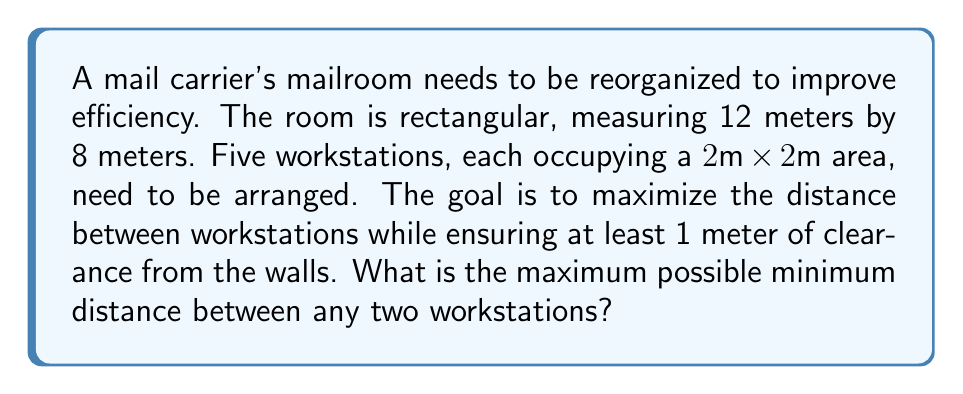Teach me how to tackle this problem. To solve this optimization problem, we'll follow these steps:

1) First, let's visualize the problem. We have a 12m x 8m room with five 2m x 2m workstations.

2) To ensure 1 meter clearance from walls, our effective area becomes 10m x 6m.

3) The objective is to maximize the minimum distance between workstations. This is achieved when the workstations are arranged in a pattern that distributes them as evenly as possible.

4) Given the rectangular shape and the number of workstations, the optimal arrangement is likely to be in a cross or plus sign pattern.

5) Let's place the workstations in this pattern:
   - One in the center
   - One each at the top, bottom, left, and right

6) To find the coordinates, we can use the following system:
   $$(0,0)$$ is the bottom-left corner of our effective area
   $$(10,6)$$ is the top-right corner

7) The coordinates of the workstations will be:
   Center: $$(5,3)$$
   Left: $$(1,3)$$
   Right: $$(9,3)$$
   Bottom: $$(5,1)$$
   Top: $$(5,5)$$

8) The minimum distance will be between the center and any of the other workstations. We can calculate this using the distance formula:

   $$d = \sqrt{(x_2-x_1)^2 + (y_2-y_1)^2}$$

9) For example, between center and left:
   $$d = \sqrt{(5-1)^2 + (3-3)^2} = \sqrt{16} = 4$$

10) This distance is the same for all four outer workstations to the center.

Therefore, the maximum possible minimum distance between any two workstations is 4 meters.
Answer: 4 meters 